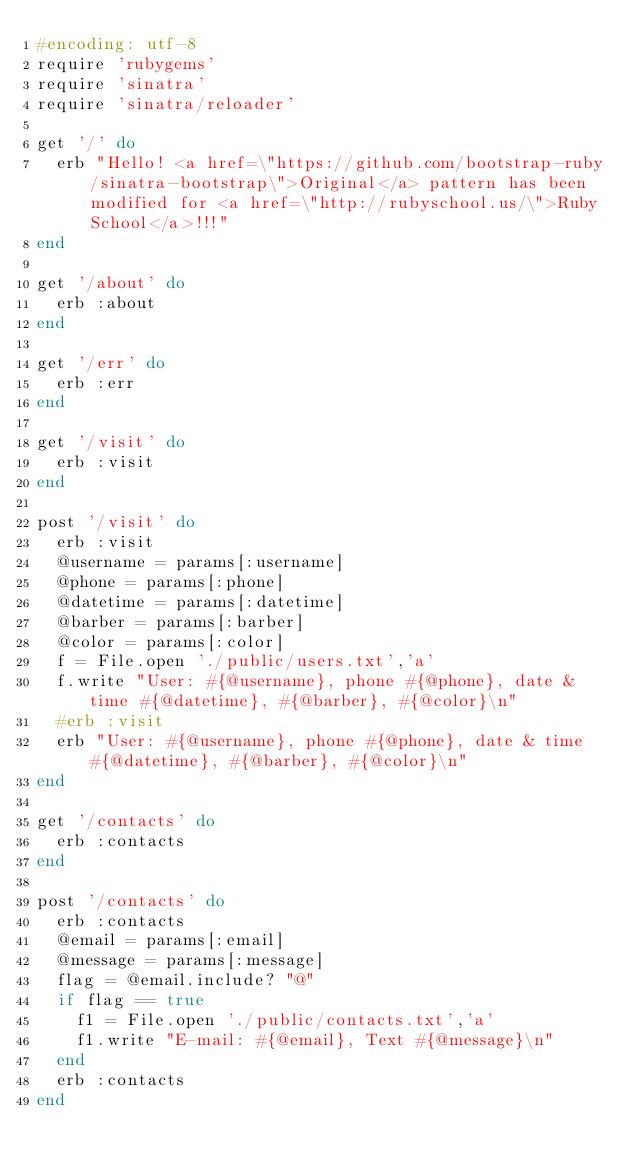<code> <loc_0><loc_0><loc_500><loc_500><_Ruby_>#encoding: utf-8
require 'rubygems'
require 'sinatra'
require 'sinatra/reloader'

get '/' do
	erb "Hello! <a href=\"https://github.com/bootstrap-ruby/sinatra-bootstrap\">Original</a> pattern has been modified for <a href=\"http://rubyschool.us/\">Ruby School</a>!!!"			
end

get '/about' do
	erb :about
end

get '/err' do
	erb :err
end

get '/visit' do
	erb :visit
end

post '/visit' do
	erb :visit
	@username = params[:username]
	@phone = params[:phone]
	@datetime = params[:datetime]
	@barber = params[:barber]
	@color = params[:color]
	f = File.open './public/users.txt','a'
	f.write "User: #{@username}, phone #{@phone}, date & time #{@datetime}, #{@barber}, #{@color}\n"
	#erb :visit
	erb "User: #{@username}, phone #{@phone}, date & time #{@datetime}, #{@barber}, #{@color}\n"
end 

get '/contacts' do
	erb :contacts
end

post '/contacts' do
	erb :contacts
	@email = params[:email]
	@message = params[:message]
	flag = @email.include? "@"
	if flag == true 
		f1 = File.open './public/contacts.txt','a'
		f1.write "E-mail: #{@email}, Text #{@message}\n"
	end
	erb :contacts
end 
</code> 